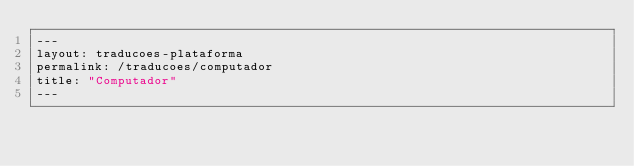Convert code to text. <code><loc_0><loc_0><loc_500><loc_500><_HTML_>---
layout: traducoes-plataforma
permalink: /traducoes/computador
title: "Computador"
---
</code> 